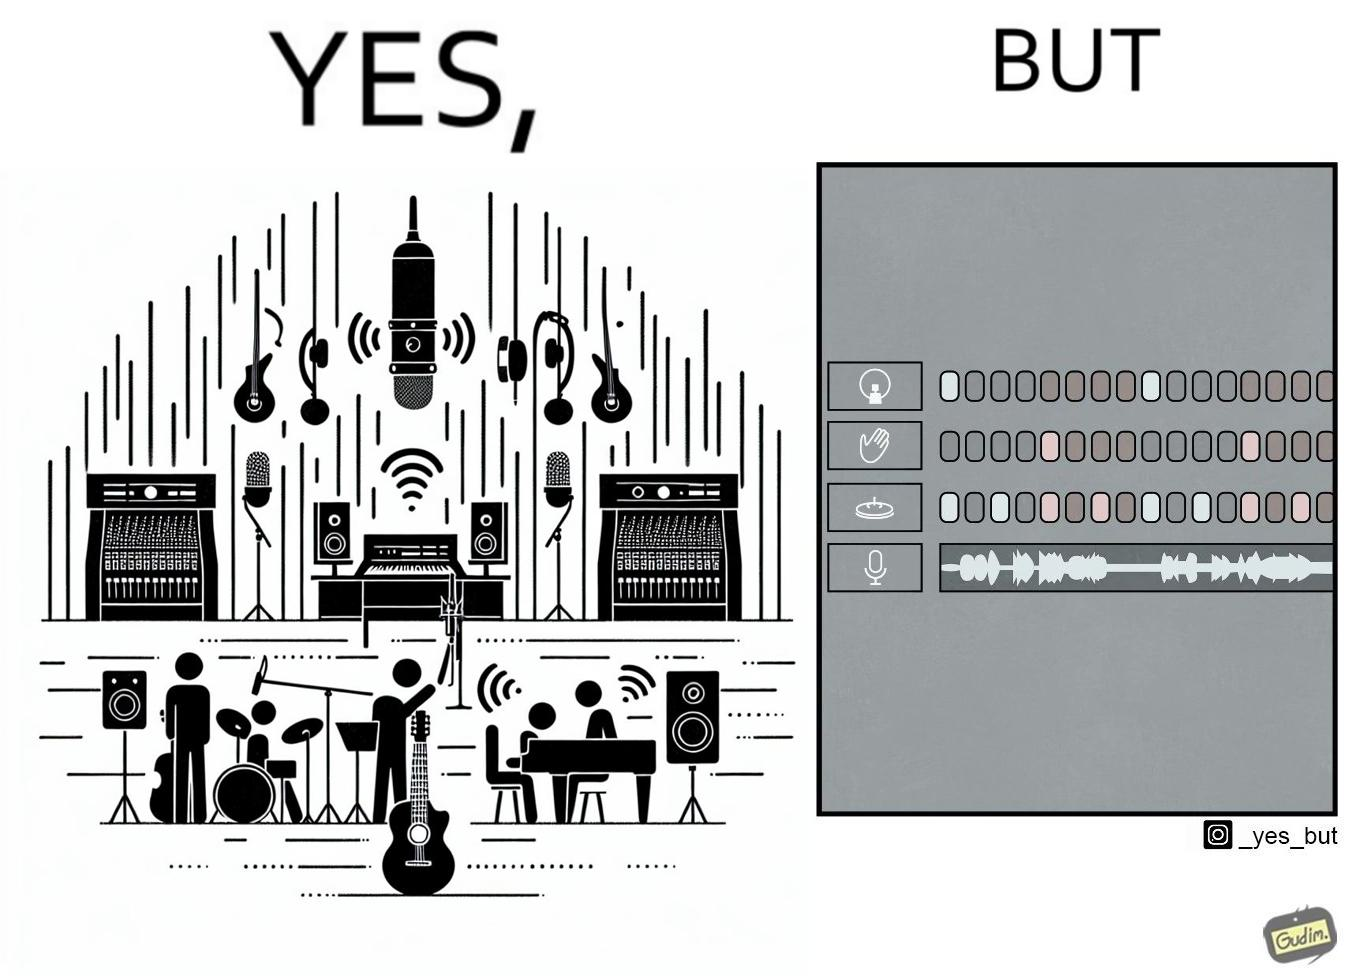What is shown in this image? The image overall is funny because even though people have great music studios and instruments to create and record music, they use electronic replacements of the musical instruments to achieve the task. 